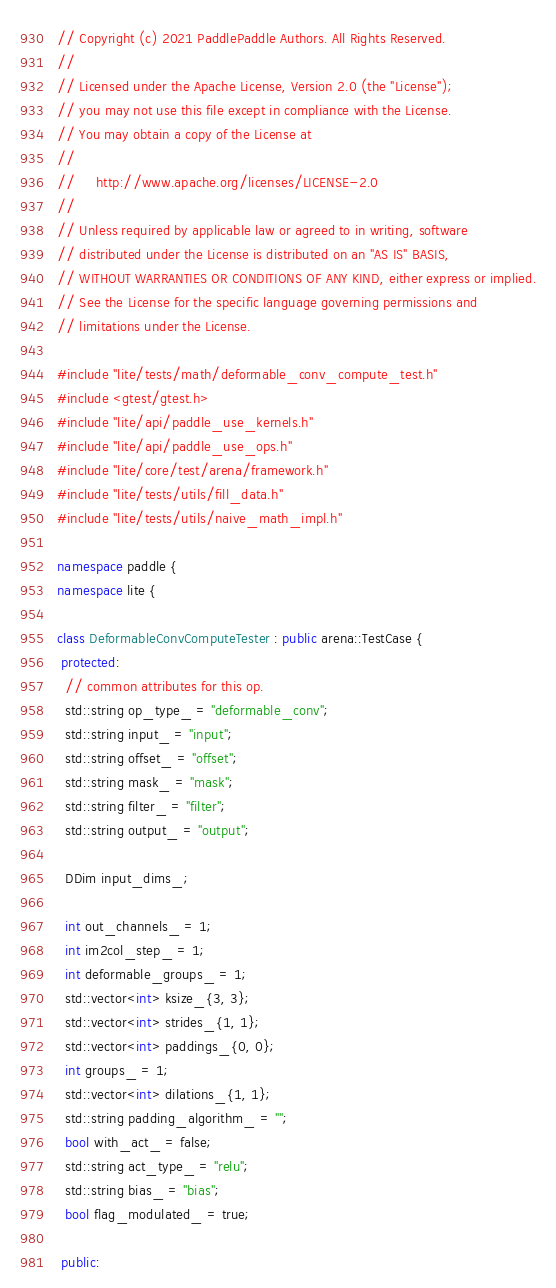<code> <loc_0><loc_0><loc_500><loc_500><_C++_>// Copyright (c) 2021 PaddlePaddle Authors. All Rights Reserved.
//
// Licensed under the Apache License, Version 2.0 (the "License");
// you may not use this file except in compliance with the License.
// You may obtain a copy of the License at
//
//     http://www.apache.org/licenses/LICENSE-2.0
//
// Unless required by applicable law or agreed to in writing, software
// distributed under the License is distributed on an "AS IS" BASIS,
// WITHOUT WARRANTIES OR CONDITIONS OF ANY KIND, either express or implied.
// See the License for the specific language governing permissions and
// limitations under the License.

#include "lite/tests/math/deformable_conv_compute_test.h"
#include <gtest/gtest.h>
#include "lite/api/paddle_use_kernels.h"
#include "lite/api/paddle_use_ops.h"
#include "lite/core/test/arena/framework.h"
#include "lite/tests/utils/fill_data.h"
#include "lite/tests/utils/naive_math_impl.h"

namespace paddle {
namespace lite {

class DeformableConvComputeTester : public arena::TestCase {
 protected:
  // common attributes for this op.
  std::string op_type_ = "deformable_conv";
  std::string input_ = "input";
  std::string offset_ = "offset";
  std::string mask_ = "mask";
  std::string filter_ = "filter";
  std::string output_ = "output";

  DDim input_dims_;

  int out_channels_ = 1;
  int im2col_step_ = 1;
  int deformable_groups_ = 1;
  std::vector<int> ksize_{3, 3};
  std::vector<int> strides_{1, 1};
  std::vector<int> paddings_{0, 0};
  int groups_ = 1;
  std::vector<int> dilations_{1, 1};
  std::string padding_algorithm_ = "";
  bool with_act_ = false;
  std::string act_type_ = "relu";
  std::string bias_ = "bias";
  bool flag_modulated_ = true;

 public:</code> 